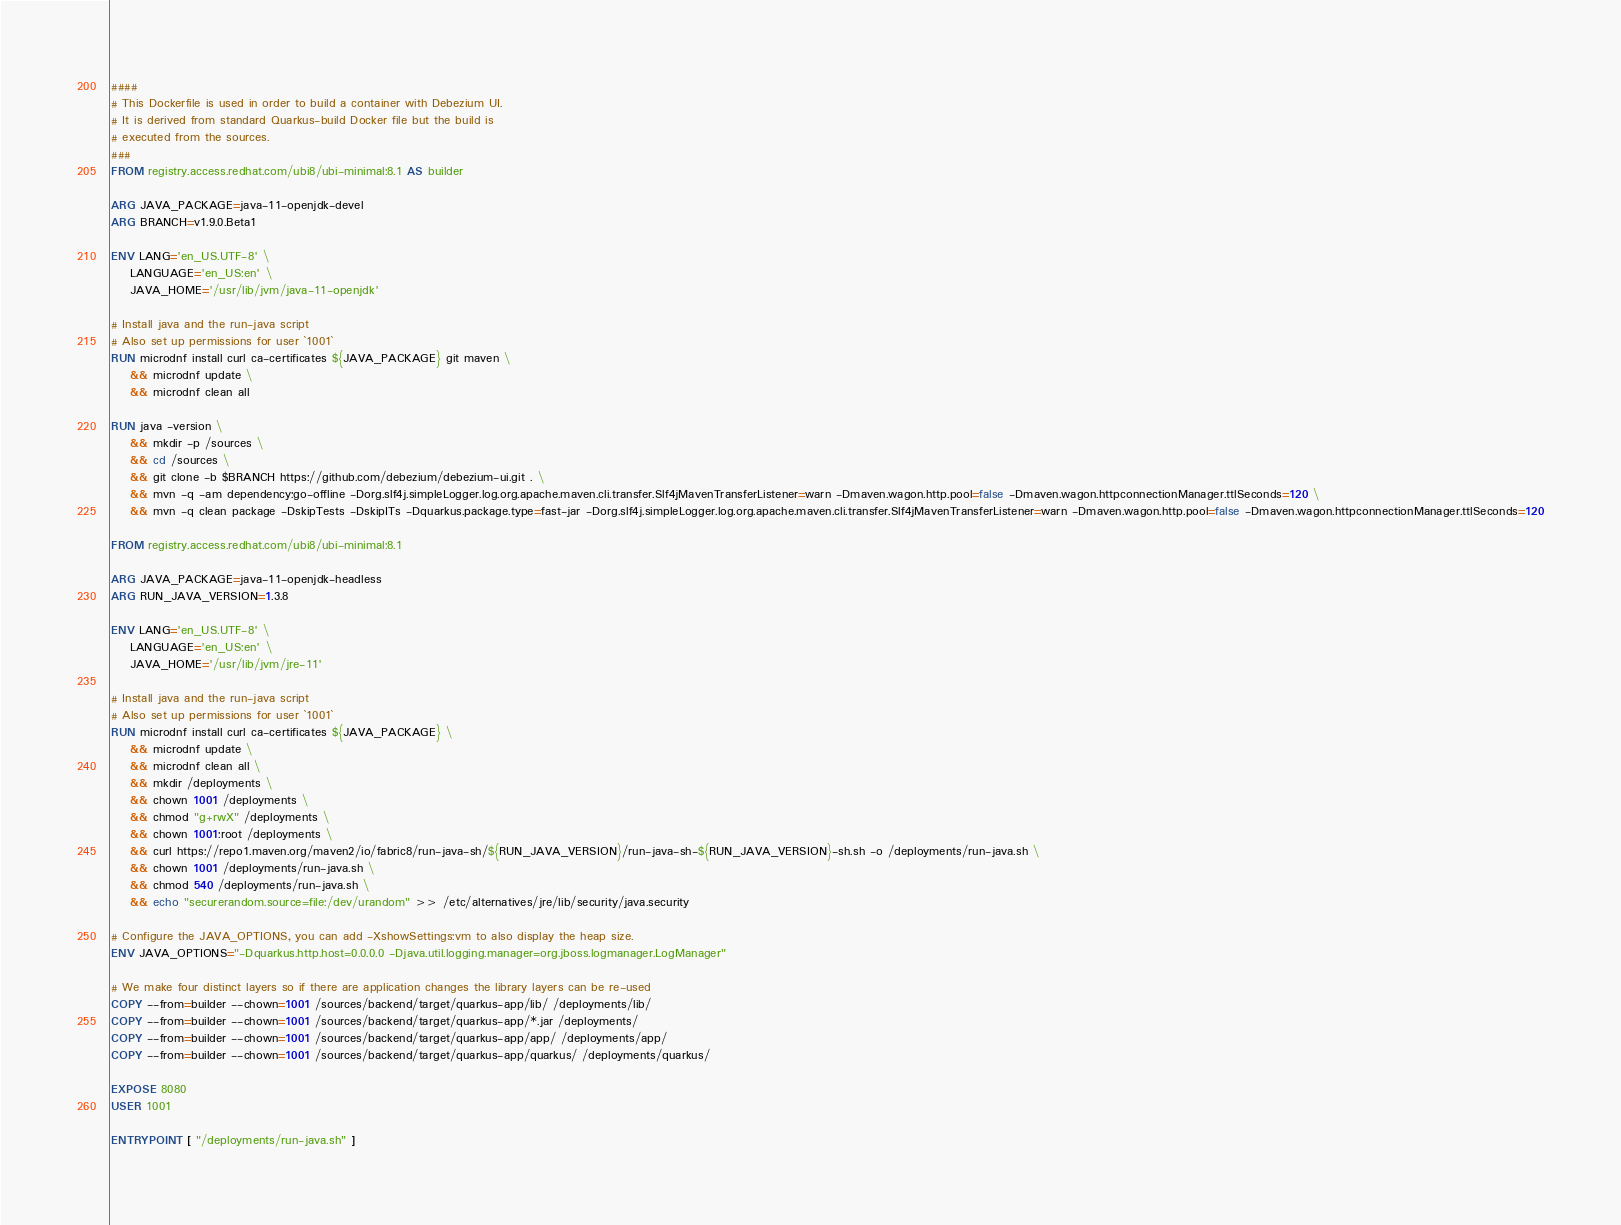Convert code to text. <code><loc_0><loc_0><loc_500><loc_500><_Dockerfile_>####
# This Dockerfile is used in order to build a container with Debezium UI.
# It is derived from standard Quarkus-build Docker file but the build is
# executed from the sources.
###
FROM registry.access.redhat.com/ubi8/ubi-minimal:8.1 AS builder

ARG JAVA_PACKAGE=java-11-openjdk-devel
ARG BRANCH=v1.9.0.Beta1

ENV LANG='en_US.UTF-8' \
    LANGUAGE='en_US:en' \
    JAVA_HOME='/usr/lib/jvm/java-11-openjdk'

# Install java and the run-java script
# Also set up permissions for user `1001`
RUN microdnf install curl ca-certificates ${JAVA_PACKAGE} git maven \
    && microdnf update \
    && microdnf clean all

RUN java -version \
    && mkdir -p /sources \
    && cd /sources \
    && git clone -b $BRANCH https://github.com/debezium/debezium-ui.git . \
    && mvn -q -am dependency:go-offline -Dorg.slf4j.simpleLogger.log.org.apache.maven.cli.transfer.Slf4jMavenTransferListener=warn -Dmaven.wagon.http.pool=false -Dmaven.wagon.httpconnectionManager.ttlSeconds=120 \
    && mvn -q clean package -DskipTests -DskipITs -Dquarkus.package.type=fast-jar -Dorg.slf4j.simpleLogger.log.org.apache.maven.cli.transfer.Slf4jMavenTransferListener=warn -Dmaven.wagon.http.pool=false -Dmaven.wagon.httpconnectionManager.ttlSeconds=120

FROM registry.access.redhat.com/ubi8/ubi-minimal:8.1

ARG JAVA_PACKAGE=java-11-openjdk-headless
ARG RUN_JAVA_VERSION=1.3.8

ENV LANG='en_US.UTF-8' \
    LANGUAGE='en_US:en' \
    JAVA_HOME='/usr/lib/jvm/jre-11'

# Install java and the run-java script
# Also set up permissions for user `1001`
RUN microdnf install curl ca-certificates ${JAVA_PACKAGE} \
    && microdnf update \
    && microdnf clean all \
    && mkdir /deployments \
    && chown 1001 /deployments \
    && chmod "g+rwX" /deployments \
    && chown 1001:root /deployments \
    && curl https://repo1.maven.org/maven2/io/fabric8/run-java-sh/${RUN_JAVA_VERSION}/run-java-sh-${RUN_JAVA_VERSION}-sh.sh -o /deployments/run-java.sh \
    && chown 1001 /deployments/run-java.sh \
    && chmod 540 /deployments/run-java.sh \
    && echo "securerandom.source=file:/dev/urandom" >> /etc/alternatives/jre/lib/security/java.security

# Configure the JAVA_OPTIONS, you can add -XshowSettings:vm to also display the heap size.
ENV JAVA_OPTIONS="-Dquarkus.http.host=0.0.0.0 -Djava.util.logging.manager=org.jboss.logmanager.LogManager"

# We make four distinct layers so if there are application changes the library layers can be re-used
COPY --from=builder --chown=1001 /sources/backend/target/quarkus-app/lib/ /deployments/lib/
COPY --from=builder --chown=1001 /sources/backend/target/quarkus-app/*.jar /deployments/
COPY --from=builder --chown=1001 /sources/backend/target/quarkus-app/app/ /deployments/app/
COPY --from=builder --chown=1001 /sources/backend/target/quarkus-app/quarkus/ /deployments/quarkus/

EXPOSE 8080
USER 1001

ENTRYPOINT [ "/deployments/run-java.sh" ]
</code> 